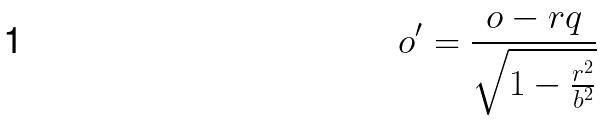Convert formula to latex. <formula><loc_0><loc_0><loc_500><loc_500>o ^ { \prime } = \frac { o - r q } { \sqrt { 1 - \frac { r ^ { 2 } } { b ^ { 2 } } } }</formula> 